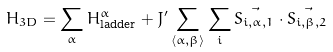Convert formula to latex. <formula><loc_0><loc_0><loc_500><loc_500>H _ { 3 D } = \sum _ { \alpha } H _ { \text {ladder} } ^ { \alpha } + J ^ { \prime } \sum _ { \langle \alpha , \beta \rangle } \sum _ { i } \vec { S _ { i , \alpha , 1 } } \cdot \vec { S _ { i , \beta , 2 } }</formula> 